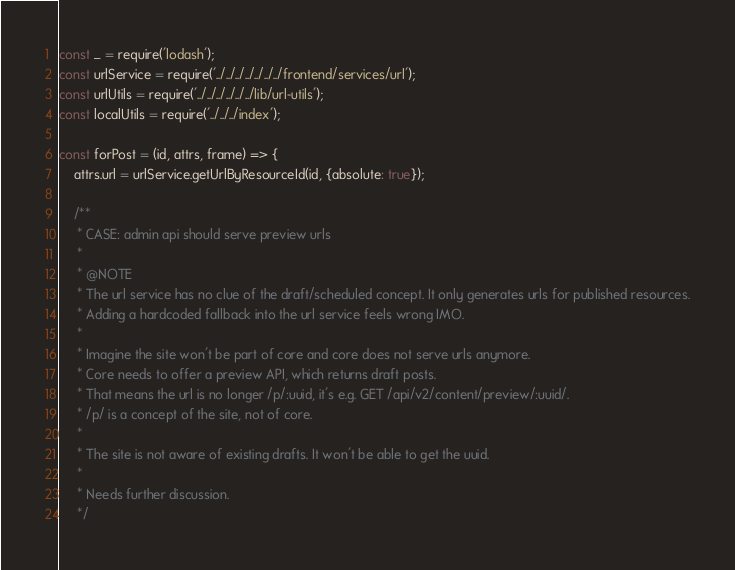<code> <loc_0><loc_0><loc_500><loc_500><_JavaScript_>const _ = require('lodash');
const urlService = require('../../../../../../../frontend/services/url');
const urlUtils = require('../../../../../../lib/url-utils');
const localUtils = require('../../../index');

const forPost = (id, attrs, frame) => {
    attrs.url = urlService.getUrlByResourceId(id, {absolute: true});

    /**
     * CASE: admin api should serve preview urls
     *
     * @NOTE
     * The url service has no clue of the draft/scheduled concept. It only generates urls for published resources.
     * Adding a hardcoded fallback into the url service feels wrong IMO.
     *
     * Imagine the site won't be part of core and core does not serve urls anymore.
     * Core needs to offer a preview API, which returns draft posts.
     * That means the url is no longer /p/:uuid, it's e.g. GET /api/v2/content/preview/:uuid/.
     * /p/ is a concept of the site, not of core.
     *
     * The site is not aware of existing drafts. It won't be able to get the uuid.
     *
     * Needs further discussion.
     */</code> 